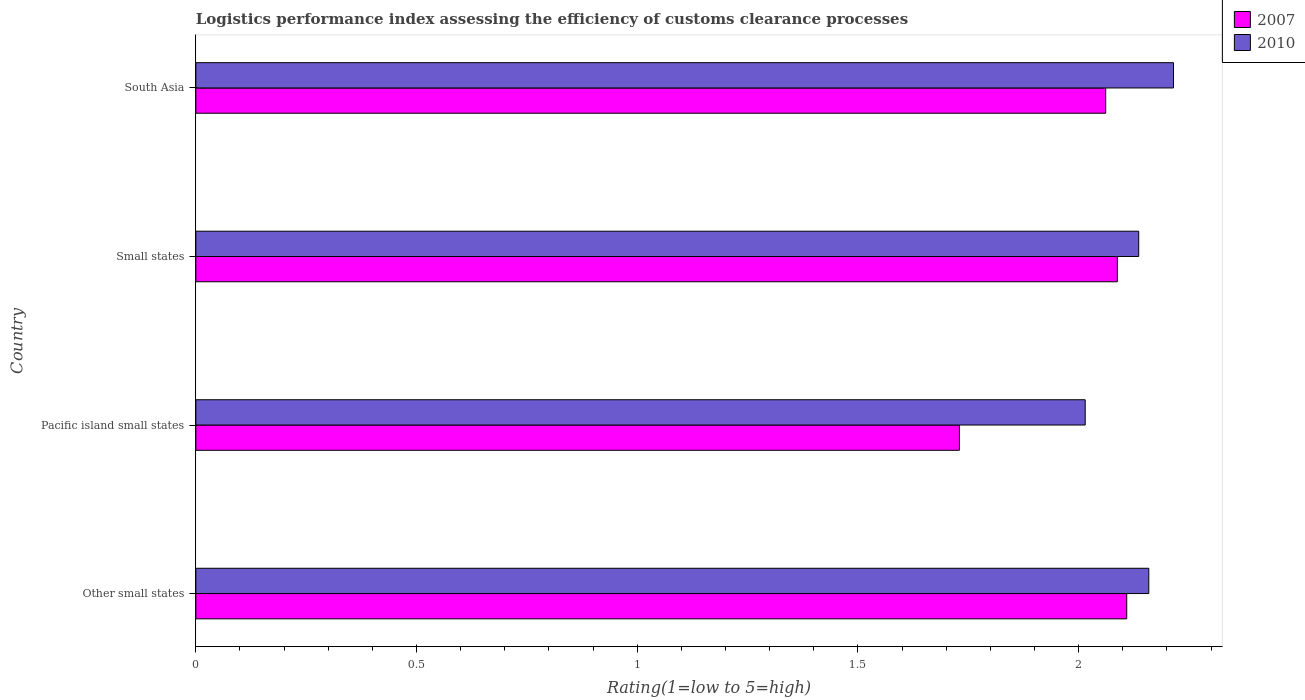How many different coloured bars are there?
Ensure brevity in your answer.  2. Are the number of bars per tick equal to the number of legend labels?
Offer a terse response. Yes. Are the number of bars on each tick of the Y-axis equal?
Ensure brevity in your answer.  Yes. What is the label of the 4th group of bars from the top?
Offer a very short reply. Other small states. In how many cases, is the number of bars for a given country not equal to the number of legend labels?
Your response must be concise. 0. What is the Logistic performance index in 2010 in South Asia?
Provide a succinct answer. 2.21. Across all countries, what is the maximum Logistic performance index in 2010?
Give a very brief answer. 2.21. Across all countries, what is the minimum Logistic performance index in 2007?
Your response must be concise. 1.73. In which country was the Logistic performance index in 2007 maximum?
Your answer should be compact. Other small states. In which country was the Logistic performance index in 2010 minimum?
Make the answer very short. Pacific island small states. What is the total Logistic performance index in 2010 in the graph?
Offer a terse response. 8.53. What is the difference between the Logistic performance index in 2007 in Other small states and that in South Asia?
Your response must be concise. 0.05. What is the difference between the Logistic performance index in 2007 in Small states and the Logistic performance index in 2010 in Pacific island small states?
Offer a very short reply. 0.07. What is the average Logistic performance index in 2007 per country?
Provide a short and direct response. 2. What is the difference between the Logistic performance index in 2010 and Logistic performance index in 2007 in Other small states?
Your answer should be compact. 0.05. In how many countries, is the Logistic performance index in 2010 greater than 0.7 ?
Keep it short and to the point. 4. What is the ratio of the Logistic performance index in 2007 in Pacific island small states to that in South Asia?
Make the answer very short. 0.84. Is the difference between the Logistic performance index in 2010 in Other small states and Small states greater than the difference between the Logistic performance index in 2007 in Other small states and Small states?
Keep it short and to the point. Yes. What is the difference between the highest and the second highest Logistic performance index in 2010?
Offer a very short reply. 0.06. What is the difference between the highest and the lowest Logistic performance index in 2007?
Make the answer very short. 0.38. What does the 2nd bar from the top in Pacific island small states represents?
Provide a short and direct response. 2007. How many bars are there?
Your answer should be very brief. 8. Are all the bars in the graph horizontal?
Offer a very short reply. Yes. What is the difference between two consecutive major ticks on the X-axis?
Provide a short and direct response. 0.5. Are the values on the major ticks of X-axis written in scientific E-notation?
Ensure brevity in your answer.  No. Does the graph contain any zero values?
Your answer should be very brief. No. Where does the legend appear in the graph?
Make the answer very short. Top right. What is the title of the graph?
Provide a succinct answer. Logistics performance index assessing the efficiency of customs clearance processes. What is the label or title of the X-axis?
Keep it short and to the point. Rating(1=low to 5=high). What is the label or title of the Y-axis?
Your answer should be very brief. Country. What is the Rating(1=low to 5=high) in 2007 in Other small states?
Keep it short and to the point. 2.11. What is the Rating(1=low to 5=high) in 2010 in Other small states?
Provide a succinct answer. 2.16. What is the Rating(1=low to 5=high) in 2007 in Pacific island small states?
Provide a short and direct response. 1.73. What is the Rating(1=low to 5=high) in 2010 in Pacific island small states?
Provide a short and direct response. 2.02. What is the Rating(1=low to 5=high) in 2007 in Small states?
Ensure brevity in your answer.  2.09. What is the Rating(1=low to 5=high) of 2010 in Small states?
Give a very brief answer. 2.14. What is the Rating(1=low to 5=high) in 2007 in South Asia?
Provide a short and direct response. 2.06. What is the Rating(1=low to 5=high) of 2010 in South Asia?
Provide a short and direct response. 2.21. Across all countries, what is the maximum Rating(1=low to 5=high) in 2007?
Your answer should be very brief. 2.11. Across all countries, what is the maximum Rating(1=low to 5=high) in 2010?
Offer a terse response. 2.21. Across all countries, what is the minimum Rating(1=low to 5=high) in 2007?
Ensure brevity in your answer.  1.73. Across all countries, what is the minimum Rating(1=low to 5=high) of 2010?
Ensure brevity in your answer.  2.02. What is the total Rating(1=low to 5=high) of 2007 in the graph?
Your response must be concise. 7.99. What is the total Rating(1=low to 5=high) of 2010 in the graph?
Offer a very short reply. 8.53. What is the difference between the Rating(1=low to 5=high) in 2007 in Other small states and that in Pacific island small states?
Your response must be concise. 0.38. What is the difference between the Rating(1=low to 5=high) in 2010 in Other small states and that in Pacific island small states?
Your answer should be very brief. 0.14. What is the difference between the Rating(1=low to 5=high) of 2007 in Other small states and that in Small states?
Give a very brief answer. 0.02. What is the difference between the Rating(1=low to 5=high) in 2010 in Other small states and that in Small states?
Your answer should be very brief. 0.02. What is the difference between the Rating(1=low to 5=high) of 2007 in Other small states and that in South Asia?
Keep it short and to the point. 0.05. What is the difference between the Rating(1=low to 5=high) in 2010 in Other small states and that in South Asia?
Make the answer very short. -0.06. What is the difference between the Rating(1=low to 5=high) of 2007 in Pacific island small states and that in Small states?
Offer a very short reply. -0.36. What is the difference between the Rating(1=low to 5=high) in 2010 in Pacific island small states and that in Small states?
Offer a very short reply. -0.12. What is the difference between the Rating(1=low to 5=high) in 2007 in Pacific island small states and that in South Asia?
Make the answer very short. -0.33. What is the difference between the Rating(1=low to 5=high) of 2007 in Small states and that in South Asia?
Keep it short and to the point. 0.03. What is the difference between the Rating(1=low to 5=high) in 2010 in Small states and that in South Asia?
Your response must be concise. -0.08. What is the difference between the Rating(1=low to 5=high) in 2007 in Other small states and the Rating(1=low to 5=high) in 2010 in Pacific island small states?
Offer a very short reply. 0.09. What is the difference between the Rating(1=low to 5=high) of 2007 in Other small states and the Rating(1=low to 5=high) of 2010 in Small states?
Give a very brief answer. -0.03. What is the difference between the Rating(1=low to 5=high) in 2007 in Other small states and the Rating(1=low to 5=high) in 2010 in South Asia?
Ensure brevity in your answer.  -0.11. What is the difference between the Rating(1=low to 5=high) of 2007 in Pacific island small states and the Rating(1=low to 5=high) of 2010 in Small states?
Your answer should be compact. -0.41. What is the difference between the Rating(1=low to 5=high) of 2007 in Pacific island small states and the Rating(1=low to 5=high) of 2010 in South Asia?
Give a very brief answer. -0.48. What is the difference between the Rating(1=low to 5=high) of 2007 in Small states and the Rating(1=low to 5=high) of 2010 in South Asia?
Offer a very short reply. -0.13. What is the average Rating(1=low to 5=high) in 2007 per country?
Offer a terse response. 2. What is the average Rating(1=low to 5=high) in 2010 per country?
Provide a short and direct response. 2.13. What is the difference between the Rating(1=low to 5=high) in 2007 and Rating(1=low to 5=high) in 2010 in Other small states?
Make the answer very short. -0.05. What is the difference between the Rating(1=low to 5=high) in 2007 and Rating(1=low to 5=high) in 2010 in Pacific island small states?
Offer a terse response. -0.28. What is the difference between the Rating(1=low to 5=high) in 2007 and Rating(1=low to 5=high) in 2010 in Small states?
Keep it short and to the point. -0.05. What is the difference between the Rating(1=low to 5=high) of 2007 and Rating(1=low to 5=high) of 2010 in South Asia?
Ensure brevity in your answer.  -0.15. What is the ratio of the Rating(1=low to 5=high) in 2007 in Other small states to that in Pacific island small states?
Your answer should be compact. 1.22. What is the ratio of the Rating(1=low to 5=high) of 2010 in Other small states to that in Pacific island small states?
Keep it short and to the point. 1.07. What is the ratio of the Rating(1=low to 5=high) in 2007 in Other small states to that in Small states?
Offer a very short reply. 1.01. What is the ratio of the Rating(1=low to 5=high) of 2010 in Other small states to that in Small states?
Provide a short and direct response. 1.01. What is the ratio of the Rating(1=low to 5=high) in 2007 in Other small states to that in South Asia?
Offer a terse response. 1.02. What is the ratio of the Rating(1=low to 5=high) of 2010 in Other small states to that in South Asia?
Provide a succinct answer. 0.97. What is the ratio of the Rating(1=low to 5=high) in 2007 in Pacific island small states to that in Small states?
Ensure brevity in your answer.  0.83. What is the ratio of the Rating(1=low to 5=high) in 2010 in Pacific island small states to that in Small states?
Provide a succinct answer. 0.94. What is the ratio of the Rating(1=low to 5=high) in 2007 in Pacific island small states to that in South Asia?
Your response must be concise. 0.84. What is the ratio of the Rating(1=low to 5=high) of 2010 in Pacific island small states to that in South Asia?
Give a very brief answer. 0.91. What is the ratio of the Rating(1=low to 5=high) of 2007 in Small states to that in South Asia?
Your response must be concise. 1.01. What is the ratio of the Rating(1=low to 5=high) in 2010 in Small states to that in South Asia?
Keep it short and to the point. 0.96. What is the difference between the highest and the second highest Rating(1=low to 5=high) in 2007?
Ensure brevity in your answer.  0.02. What is the difference between the highest and the second highest Rating(1=low to 5=high) of 2010?
Your answer should be compact. 0.06. What is the difference between the highest and the lowest Rating(1=low to 5=high) in 2007?
Offer a very short reply. 0.38. What is the difference between the highest and the lowest Rating(1=low to 5=high) of 2010?
Offer a very short reply. 0.2. 